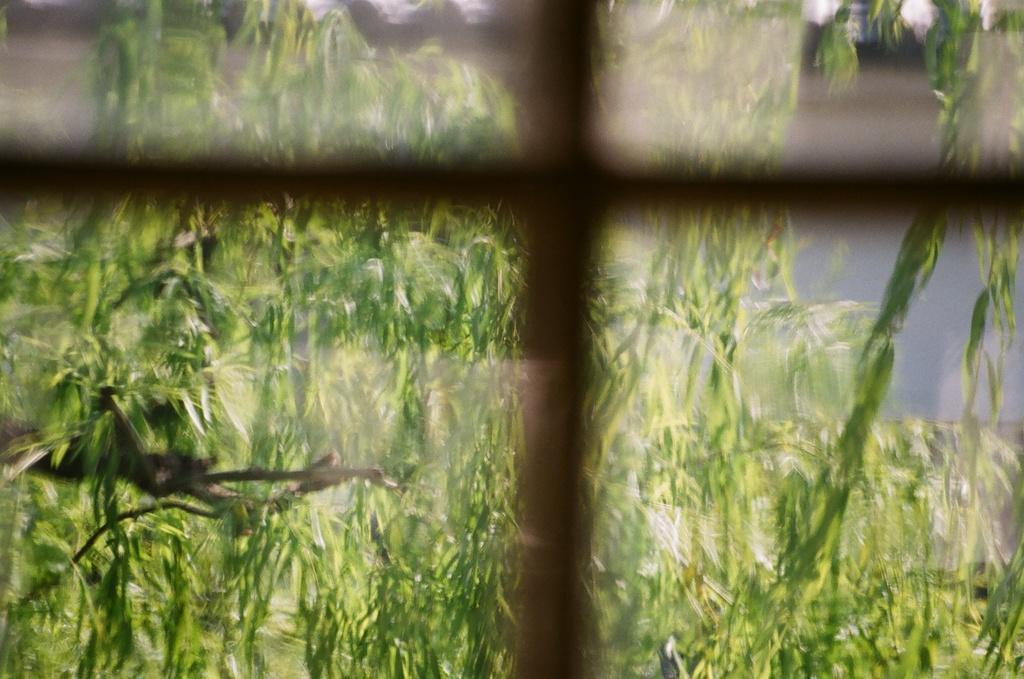How would you summarize this image in a sentence or two? In this image I can see green colour leaves. I can also see this image is little bit blurry. 